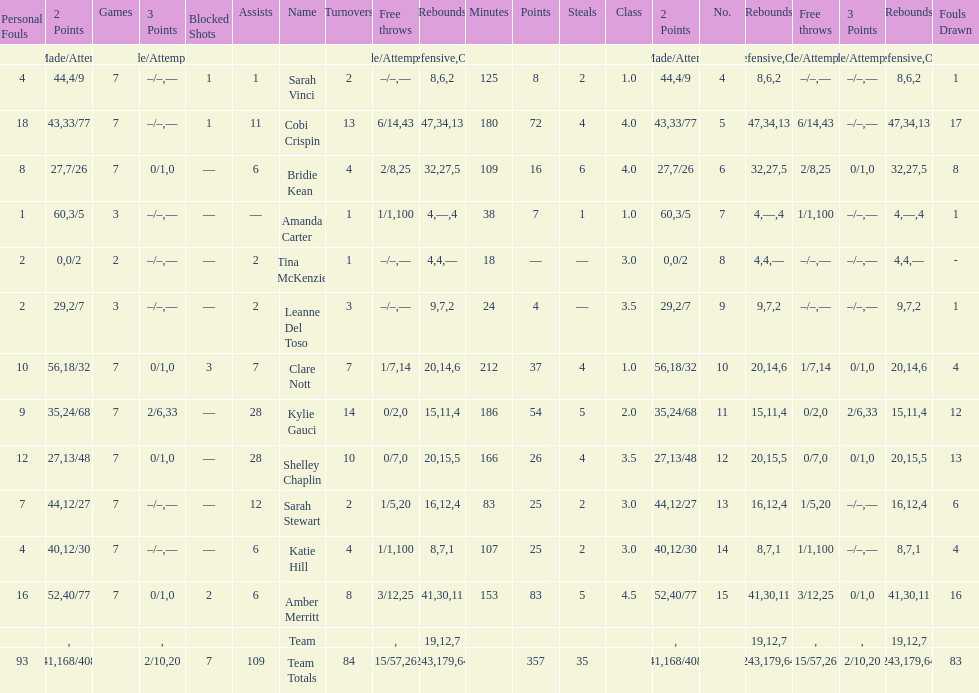Who is the first person on the list to play less than 20 minutes? Tina McKenzie. 